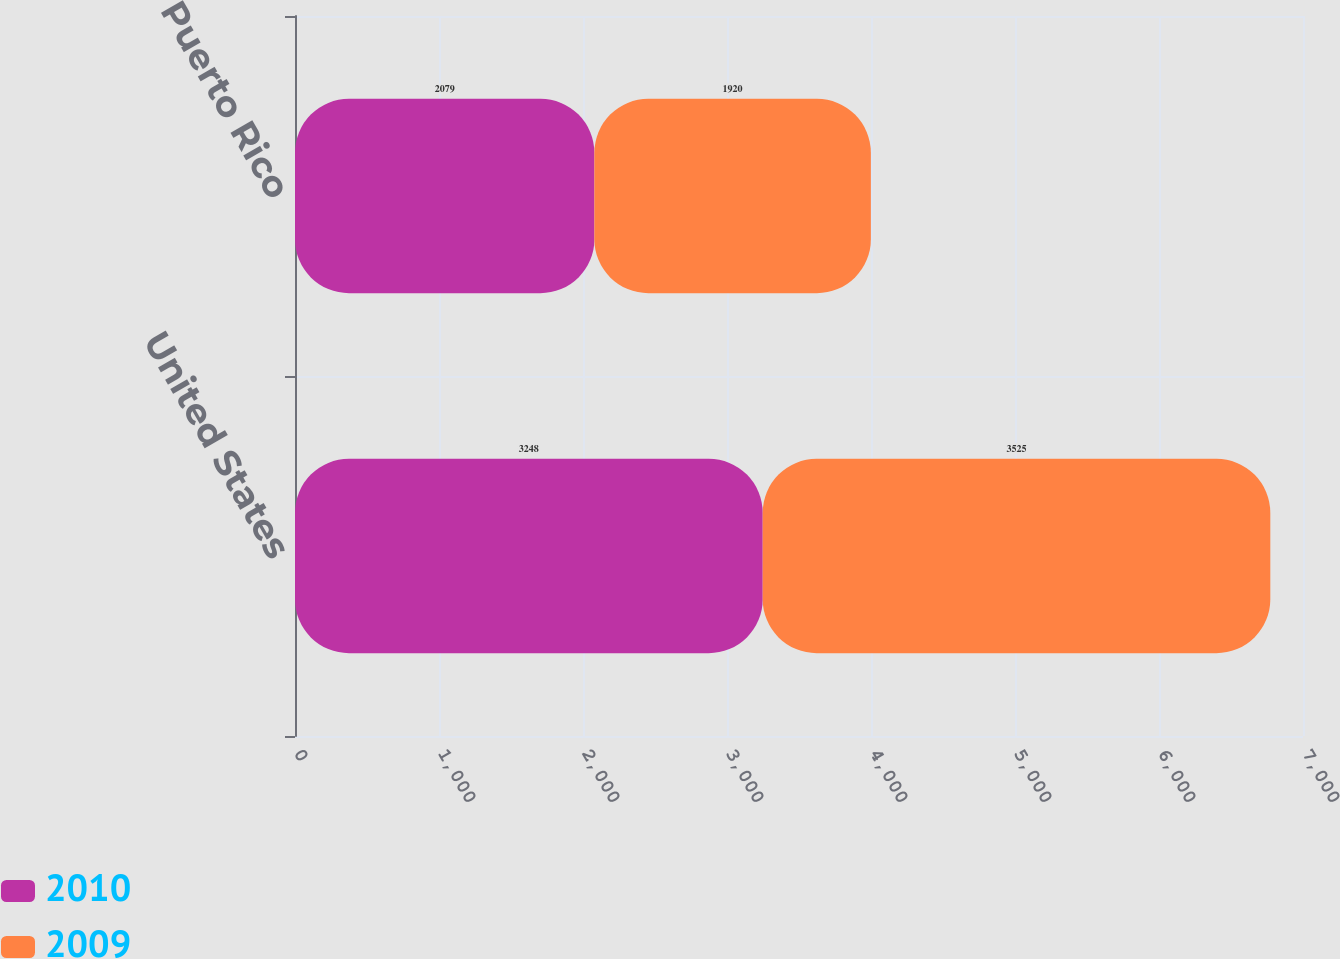Convert chart. <chart><loc_0><loc_0><loc_500><loc_500><stacked_bar_chart><ecel><fcel>United States<fcel>Puerto Rico<nl><fcel>2010<fcel>3248<fcel>2079<nl><fcel>2009<fcel>3525<fcel>1920<nl></chart> 